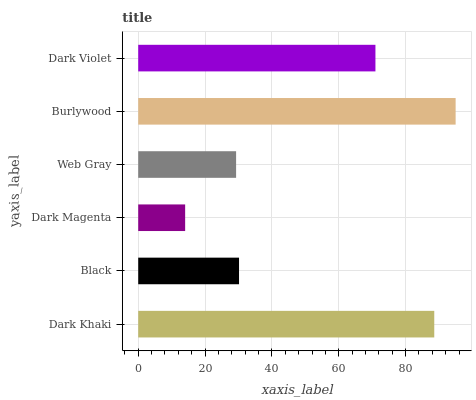Is Dark Magenta the minimum?
Answer yes or no. Yes. Is Burlywood the maximum?
Answer yes or no. Yes. Is Black the minimum?
Answer yes or no. No. Is Black the maximum?
Answer yes or no. No. Is Dark Khaki greater than Black?
Answer yes or no. Yes. Is Black less than Dark Khaki?
Answer yes or no. Yes. Is Black greater than Dark Khaki?
Answer yes or no. No. Is Dark Khaki less than Black?
Answer yes or no. No. Is Dark Violet the high median?
Answer yes or no. Yes. Is Black the low median?
Answer yes or no. Yes. Is Dark Khaki the high median?
Answer yes or no. No. Is Dark Khaki the low median?
Answer yes or no. No. 